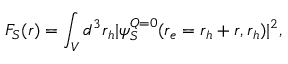Convert formula to latex. <formula><loc_0><loc_0><loc_500><loc_500>F _ { S } ( r ) = \int _ { V } d ^ { 3 } r _ { h } | \psi _ { S } ^ { Q = 0 } ( r _ { e } = r _ { h } + r , r _ { h } ) | ^ { 2 } ,</formula> 